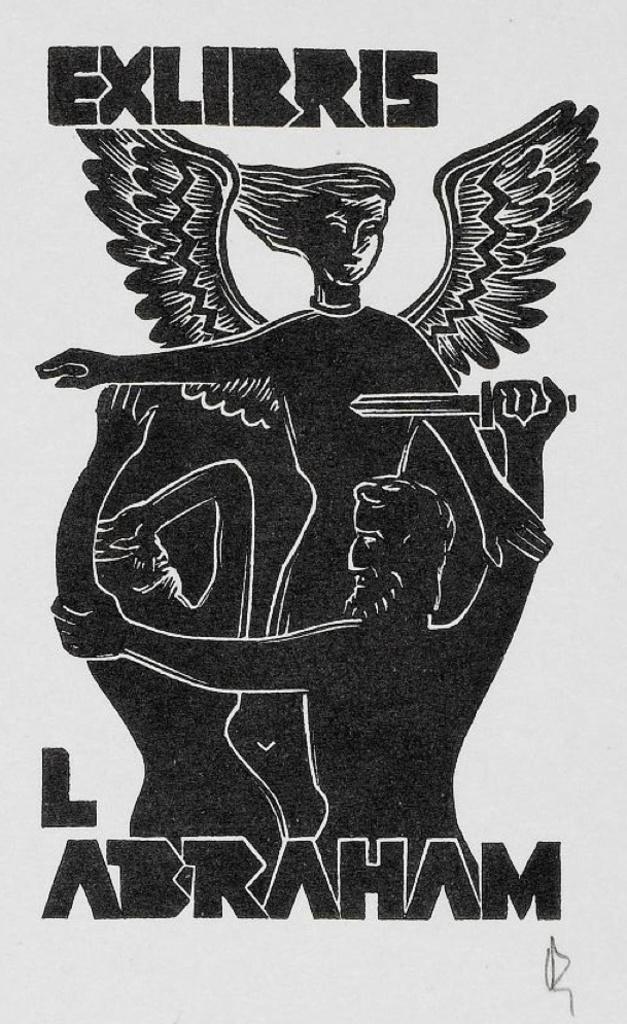Describe this image in one or two sentences. This might be a poster in this image, at the top and bottom there is text. And in the center there is an image of three people and there is white background. 